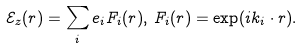<formula> <loc_0><loc_0><loc_500><loc_500>\mathcal { E } _ { z } ( r ) = \sum _ { i } e _ { i } F _ { i } ( r ) , \, F _ { i } ( r ) = \exp ( i k _ { i } \cdot r ) .</formula> 